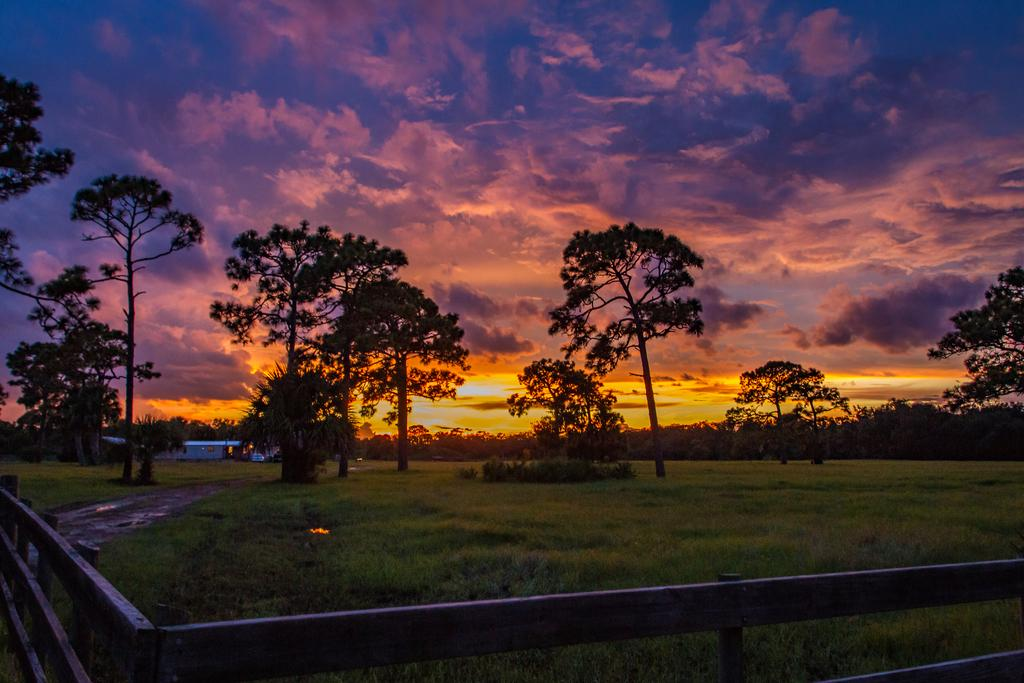What can be seen in the image that might be used for support or safety? There is a railing in the image that might be used for support or safety. What type of natural environment is visible in the background of the image? There are many trees and the ground visible in the background of the image, suggesting a natural setting. What type of structure can be seen in the background of the image? There is a house in the background of the image. What is visible in the sky in the background of the image? Clouds and the sky are visible in the background of the image. How many rabbits are hopping on the railing in the image? There are no rabbits present in the image, so it is not possible to determine how many might be hopping on the railing. 